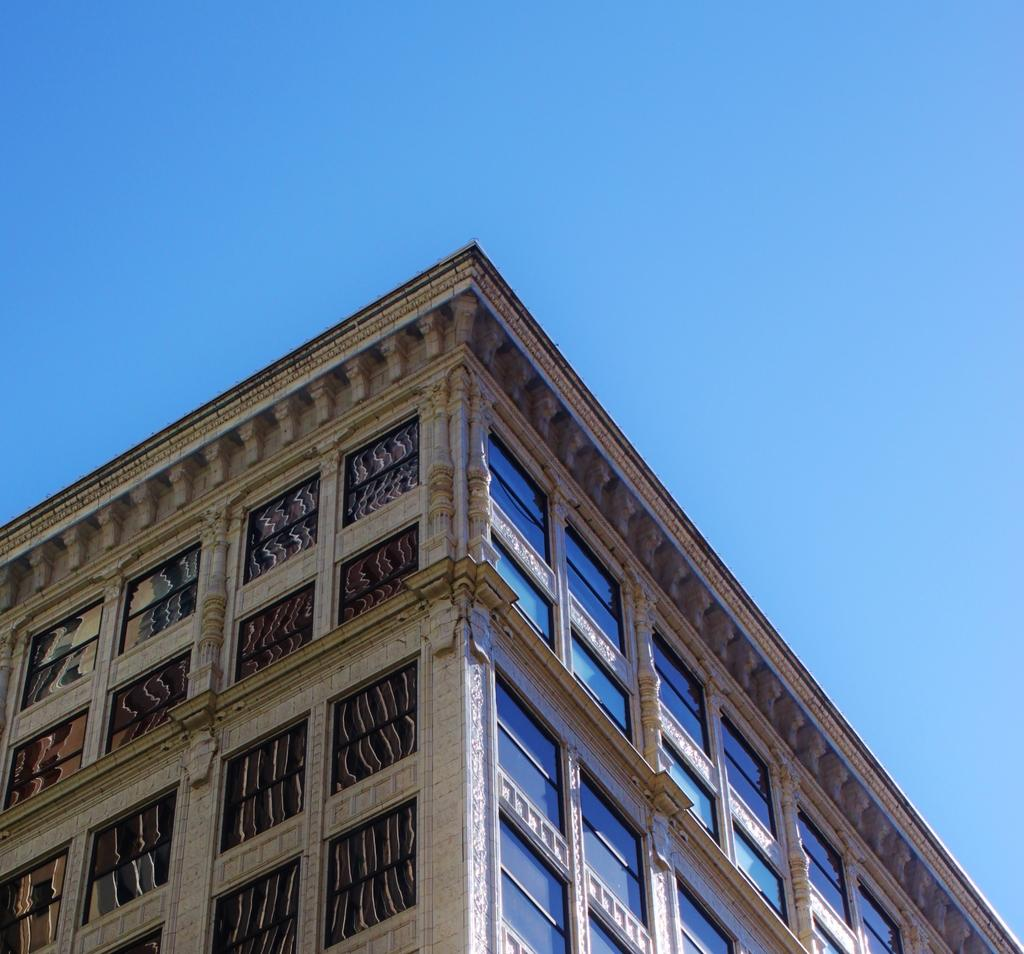What is the main subject of the picture? The main subject of the picture is a building. What specific features can be observed on the building? The building has windows. What can be seen in the background of the picture? The sky is visible in the background of the picture. What type of note is the building playing in the image? There is no note or musical instrument present in the image, so it cannot be determined if the building is playing anything. 